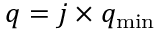<formula> <loc_0><loc_0><loc_500><loc_500>q = j \times q _ { \min }</formula> 